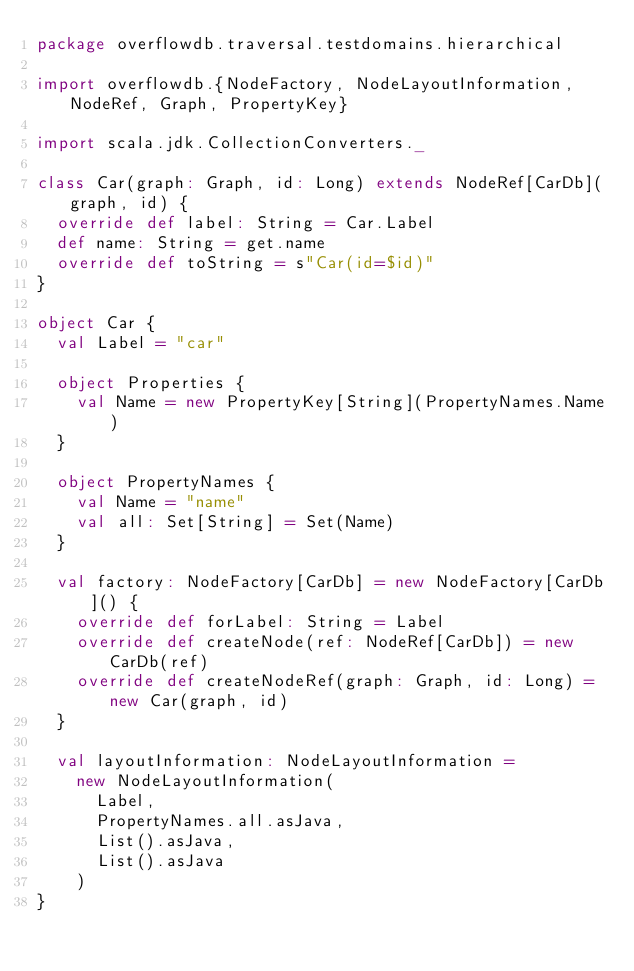Convert code to text. <code><loc_0><loc_0><loc_500><loc_500><_Scala_>package overflowdb.traversal.testdomains.hierarchical

import overflowdb.{NodeFactory, NodeLayoutInformation, NodeRef, Graph, PropertyKey}

import scala.jdk.CollectionConverters._

class Car(graph: Graph, id: Long) extends NodeRef[CarDb](graph, id) {
  override def label: String = Car.Label
  def name: String = get.name
  override def toString = s"Car(id=$id)"
}

object Car {
  val Label = "car"

  object Properties {
    val Name = new PropertyKey[String](PropertyNames.Name)
  }

  object PropertyNames {
    val Name = "name"
    val all: Set[String] = Set(Name)
  }

  val factory: NodeFactory[CarDb] = new NodeFactory[CarDb]() {
    override def forLabel: String = Label
    override def createNode(ref: NodeRef[CarDb]) = new CarDb(ref)
    override def createNodeRef(graph: Graph, id: Long) = new Car(graph, id)
  }

  val layoutInformation: NodeLayoutInformation =
    new NodeLayoutInformation(
      Label,
      PropertyNames.all.asJava,
      List().asJava,
      List().asJava
    )
}
</code> 